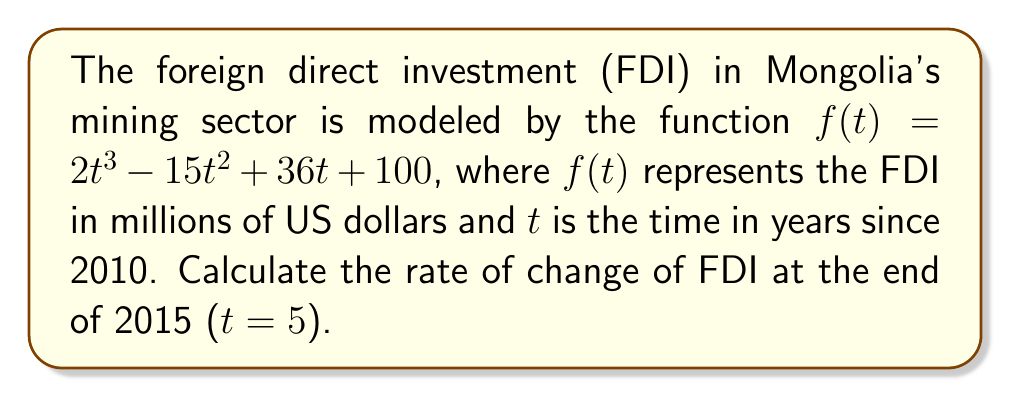Can you answer this question? To find the rate of change of FDI at t = 5, we need to calculate the derivative of the function f(t) and evaluate it at t = 5.

Step 1: Find the derivative of f(t).
$$f(t) = 2t^3 - 15t^2 + 36t + 100$$
$$f'(t) = 6t^2 - 30t + 36$$

Step 2: Evaluate f'(t) at t = 5.
$$f'(5) = 6(5^2) - 30(5) + 36$$
$$f'(5) = 6(25) - 150 + 36$$
$$f'(5) = 150 - 150 + 36$$
$$f'(5) = 36$$

The rate of change of FDI at the end of 2015 (t = 5) is 36 million US dollars per year.
Answer: $36$ million USD/year 